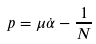<formula> <loc_0><loc_0><loc_500><loc_500>p = \mu \dot { \alpha } - \frac { 1 } { N }</formula> 